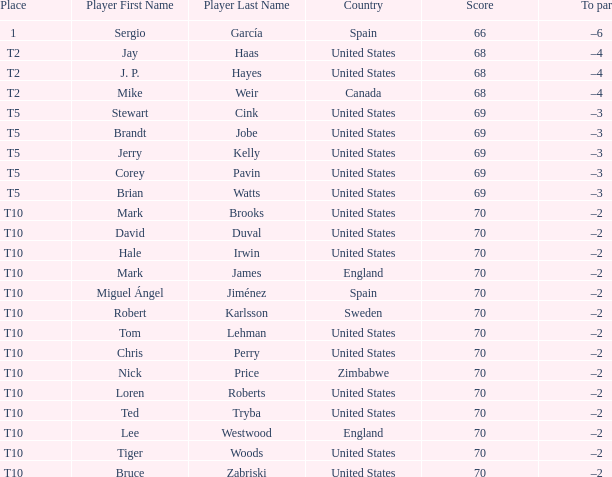Which player had a score of 70? Mark Brooks, David Duval, Hale Irwin, Mark James, Miguel Ángel Jiménez, Robert Karlsson, Tom Lehman, Chris Perry, Nick Price, Loren Roberts, Ted Tryba, Lee Westwood, Tiger Woods, Bruce Zabriski. 